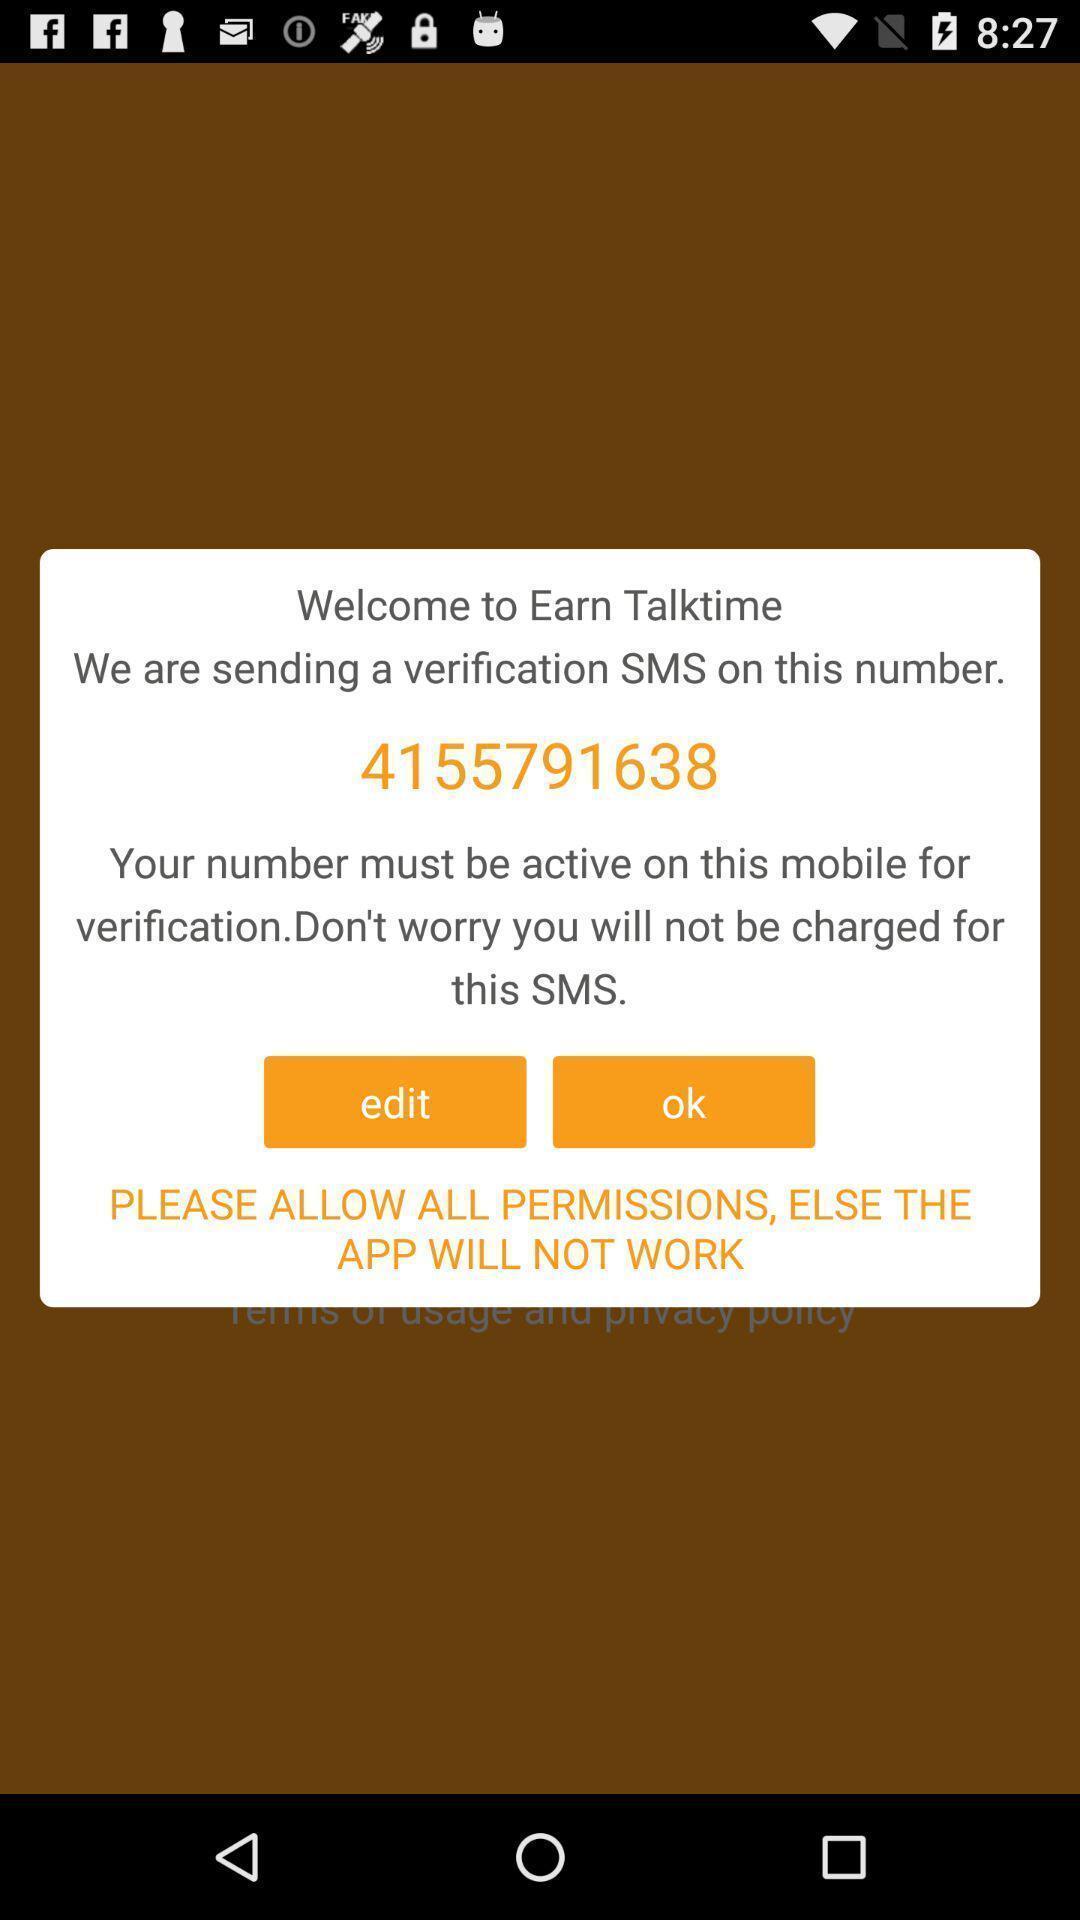Describe the key features of this screenshot. Welcome page. 